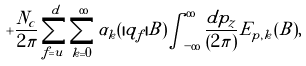<formula> <loc_0><loc_0><loc_500><loc_500>+ \frac { N _ { c } } { 2 \pi } \sum _ { f = u } ^ { d } \sum _ { k = 0 } ^ { \infty } \alpha _ { k } ( | q _ { f } | B ) \int _ { - \infty } ^ { \infty } \frac { d p _ { z } } { ( 2 \pi ) } E _ { p , k } ( B ) ,</formula> 